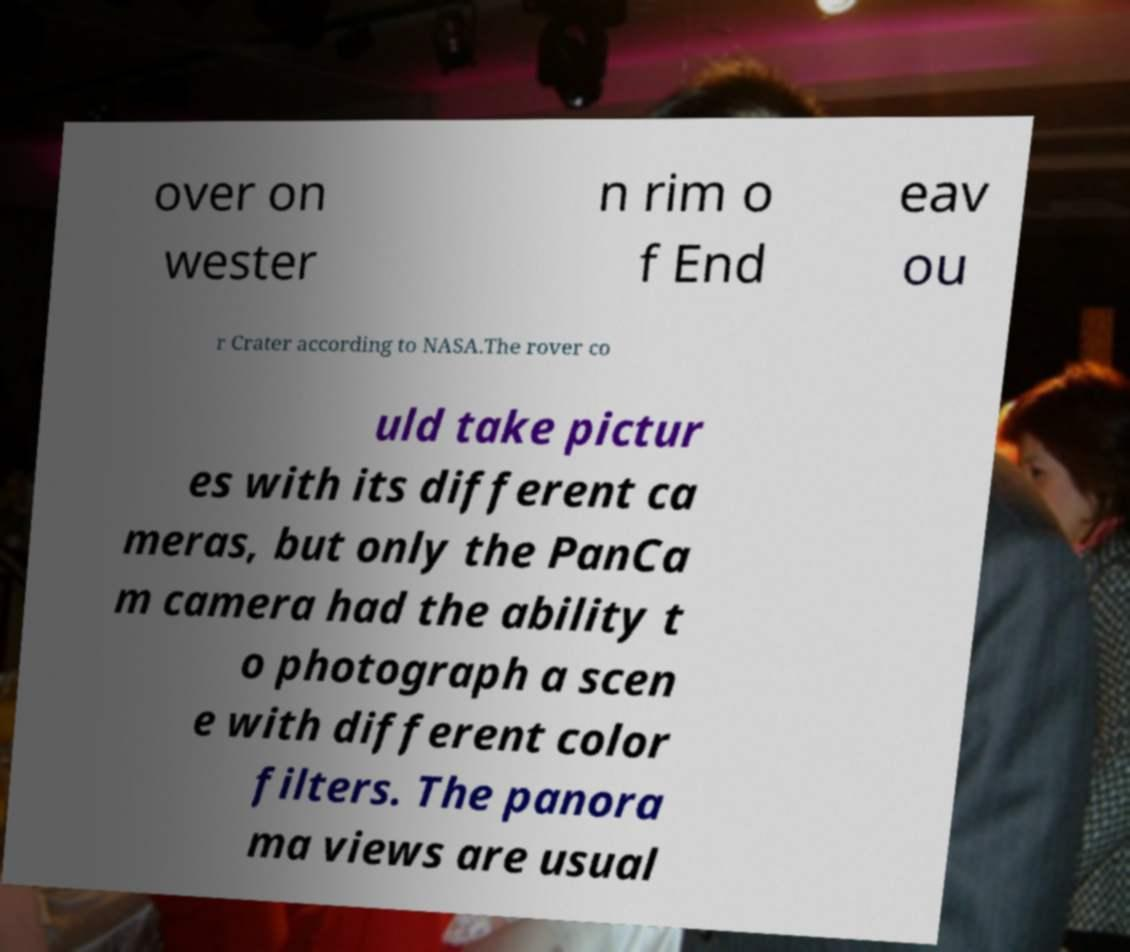Could you assist in decoding the text presented in this image and type it out clearly? over on wester n rim o f End eav ou r Crater according to NASA.The rover co uld take pictur es with its different ca meras, but only the PanCa m camera had the ability t o photograph a scen e with different color filters. The panora ma views are usual 